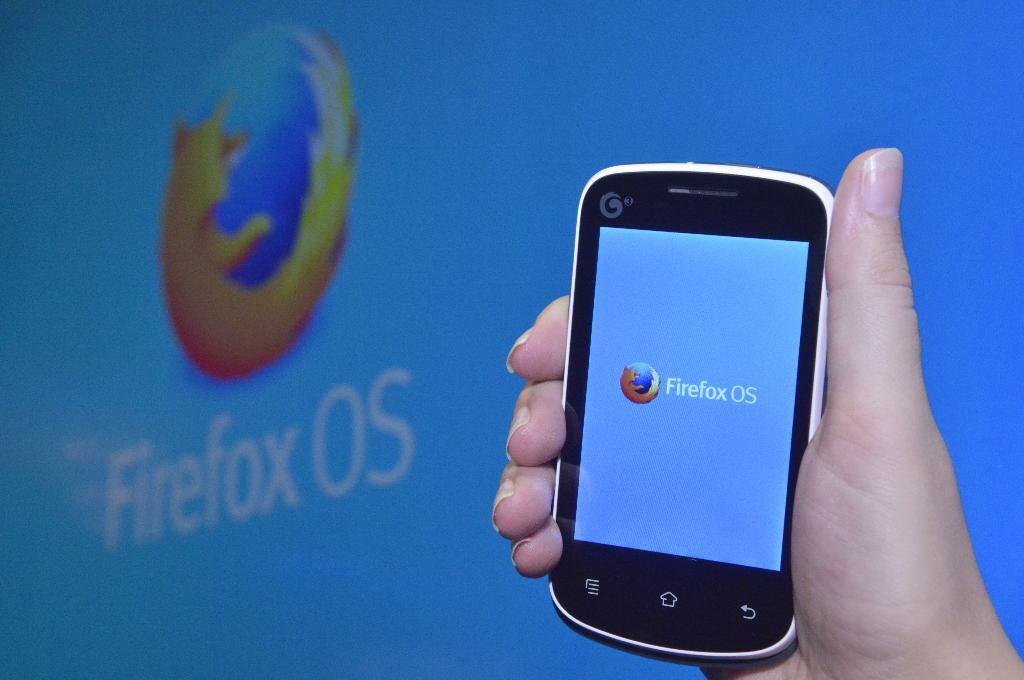<image>
Provide a brief description of the given image. Someone is holding a phone that is running Firefox OS. 